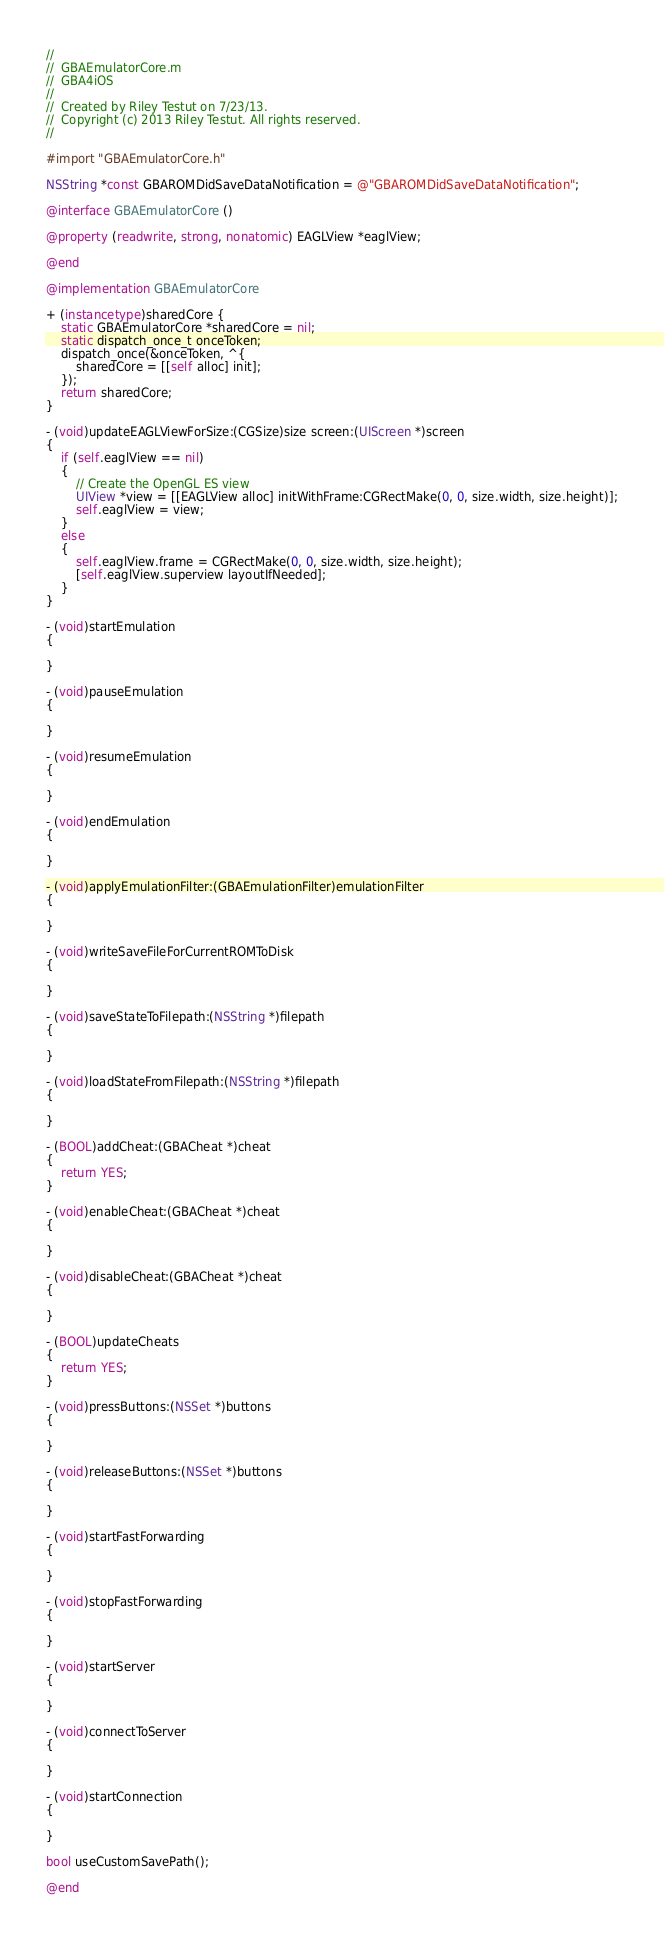Convert code to text. <code><loc_0><loc_0><loc_500><loc_500><_ObjectiveC_>//
//  GBAEmulatorCore.m
//  GBA4iOS
//
//  Created by Riley Testut on 7/23/13.
//  Copyright (c) 2013 Riley Testut. All rights reserved.
//

#import "GBAEmulatorCore.h"

NSString *const GBAROMDidSaveDataNotification = @"GBAROMDidSaveDataNotification";

@interface GBAEmulatorCore ()

@property (readwrite, strong, nonatomic) EAGLView *eaglView;

@end

@implementation GBAEmulatorCore

+ (instancetype)sharedCore {
    static GBAEmulatorCore *sharedCore = nil;
    static dispatch_once_t onceToken;
    dispatch_once(&onceToken, ^{
        sharedCore = [[self alloc] init];
    });
    return sharedCore;
}

- (void)updateEAGLViewForSize:(CGSize)size screen:(UIScreen *)screen
{
    if (self.eaglView == nil)
    {
        // Create the OpenGL ES view
        UIView *view = [[EAGLView alloc] initWithFrame:CGRectMake(0, 0, size.width, size.height)];
        self.eaglView = view;
    }
    else
    {
        self.eaglView.frame = CGRectMake(0, 0, size.width, size.height);
        [self.eaglView.superview layoutIfNeeded];
    }
}

- (void)startEmulation
{
    
}

- (void)pauseEmulation
{
    
}

- (void)resumeEmulation
{
    
}

- (void)endEmulation
{
    
}

- (void)applyEmulationFilter:(GBAEmulationFilter)emulationFilter
{
    
}

- (void)writeSaveFileForCurrentROMToDisk
{
    
}

- (void)saveStateToFilepath:(NSString *)filepath
{
    
}

- (void)loadStateFromFilepath:(NSString *)filepath
{
    
}

- (BOOL)addCheat:(GBACheat *)cheat
{
    return YES;
}

- (void)enableCheat:(GBACheat *)cheat
{
    
}

- (void)disableCheat:(GBACheat *)cheat
{
    
}

- (BOOL)updateCheats
{
    return YES;
}

- (void)pressButtons:(NSSet *)buttons
{
    
}

- (void)releaseButtons:(NSSet *)buttons
{
    
}

- (void)startFastForwarding
{
    
}

- (void)stopFastForwarding
{
    
}

- (void)startServer
{
    
}

- (void)connectToServer
{
    
}

- (void)startConnection
{
    
}

bool useCustomSavePath();

@end
</code> 